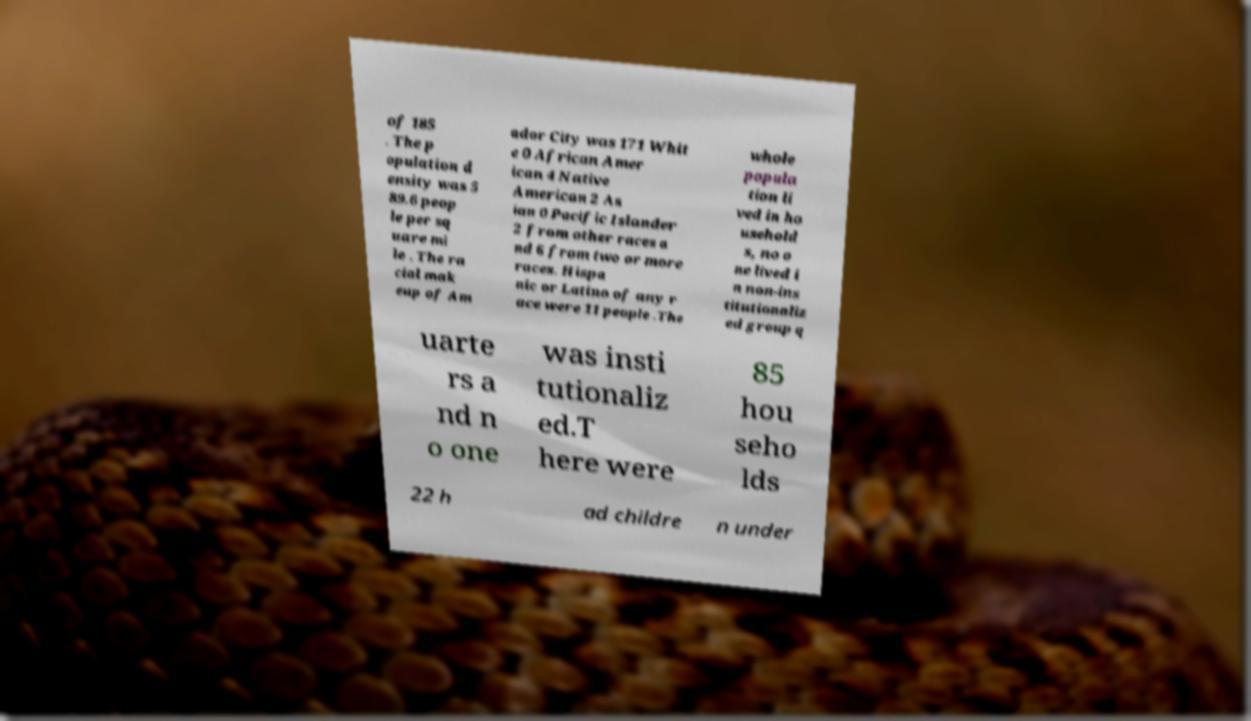For documentation purposes, I need the text within this image transcribed. Could you provide that? of 185 . The p opulation d ensity was 5 89.6 peop le per sq uare mi le . The ra cial mak eup of Am ador City was 171 Whit e 0 African Amer ican 4 Native American 2 As ian 0 Pacific Islander 2 from other races a nd 6 from two or more races. Hispa nic or Latino of any r ace were 11 people .The whole popula tion li ved in ho usehold s, no o ne lived i n non-ins titutionaliz ed group q uarte rs a nd n o one was insti tutionaliz ed.T here were 85 hou seho lds 22 h ad childre n under 